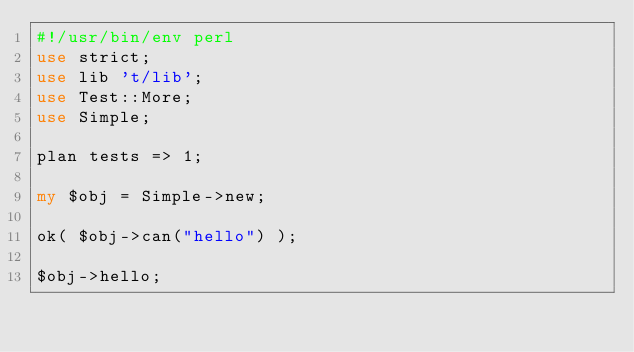Convert code to text. <code><loc_0><loc_0><loc_500><loc_500><_Perl_>#!/usr/bin/env perl
use strict;
use lib 't/lib';
use Test::More;
use Simple;

plan tests => 1;

my $obj = Simple->new;

ok( $obj->can("hello") );

$obj->hello;

</code> 